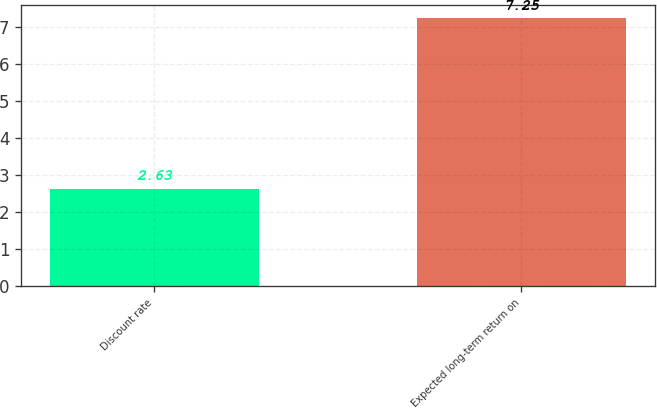<chart> <loc_0><loc_0><loc_500><loc_500><bar_chart><fcel>Discount rate<fcel>Expected long-term return on<nl><fcel>2.63<fcel>7.25<nl></chart> 